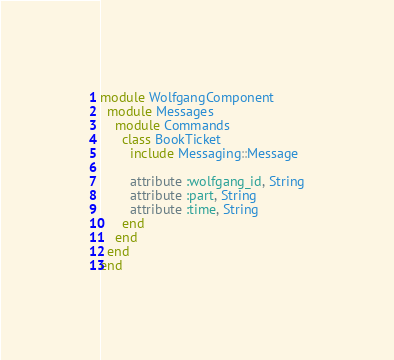Convert code to text. <code><loc_0><loc_0><loc_500><loc_500><_Ruby_>module WolfgangComponent
  module Messages
    module Commands
      class BookTicket
        include Messaging::Message

        attribute :wolfgang_id, String
        attribute :part, String
        attribute :time, String
      end
    end
  end
end
</code> 